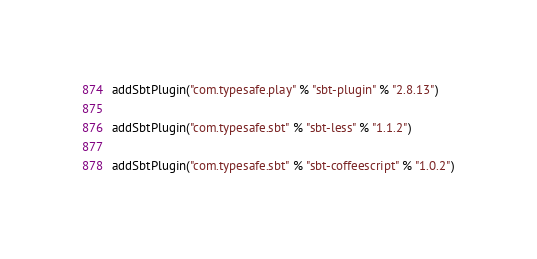<code> <loc_0><loc_0><loc_500><loc_500><_Scala_>addSbtPlugin("com.typesafe.play" % "sbt-plugin" % "2.8.13")

addSbtPlugin("com.typesafe.sbt" % "sbt-less" % "1.1.2")

addSbtPlugin("com.typesafe.sbt" % "sbt-coffeescript" % "1.0.2")
</code> 